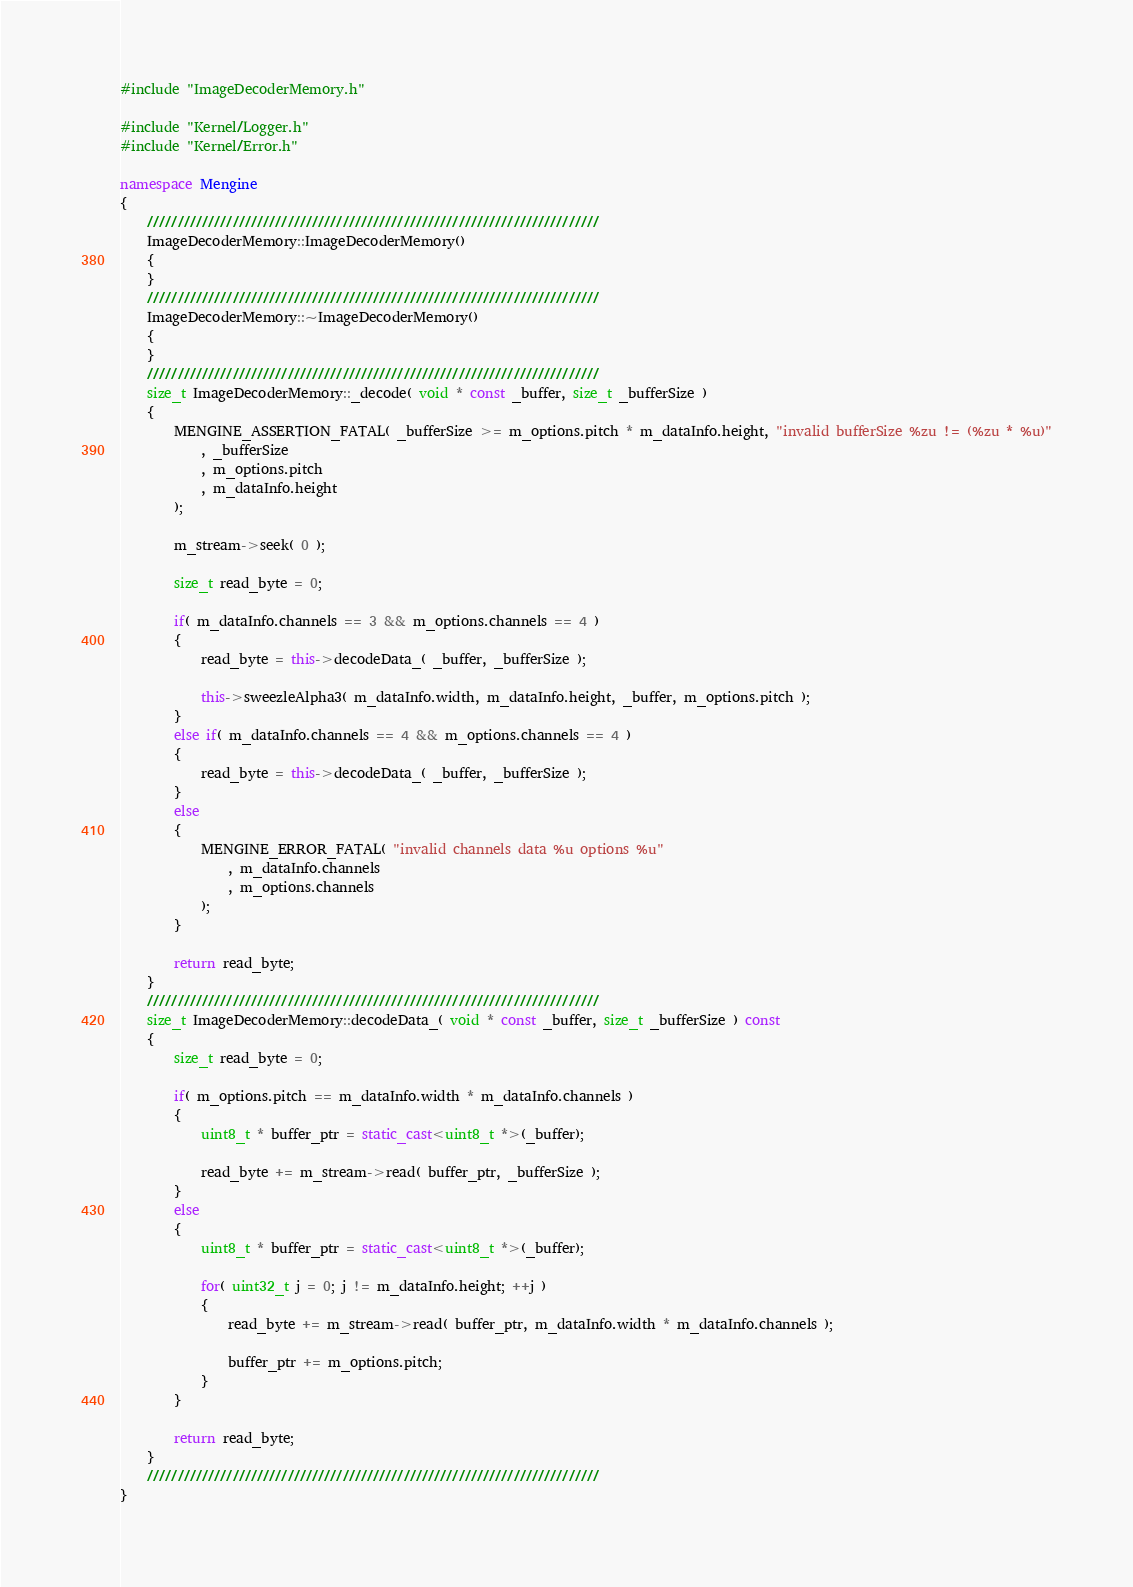Convert code to text. <code><loc_0><loc_0><loc_500><loc_500><_C++_>#include "ImageDecoderMemory.h"

#include "Kernel/Logger.h"
#include "Kernel/Error.h"

namespace Mengine
{
    //////////////////////////////////////////////////////////////////////////
    ImageDecoderMemory::ImageDecoderMemory()
    {
    }
    //////////////////////////////////////////////////////////////////////////
    ImageDecoderMemory::~ImageDecoderMemory()
    {
    }
    //////////////////////////////////////////////////////////////////////////
    size_t ImageDecoderMemory::_decode( void * const _buffer, size_t _bufferSize )
    {
        MENGINE_ASSERTION_FATAL( _bufferSize >= m_options.pitch * m_dataInfo.height, "invalid bufferSize %zu != (%zu * %u)"
            , _bufferSize
            , m_options.pitch
            , m_dataInfo.height
        );

        m_stream->seek( 0 );

        size_t read_byte = 0;

        if( m_dataInfo.channels == 3 && m_options.channels == 4 )
        {
            read_byte = this->decodeData_( _buffer, _bufferSize );

            this->sweezleAlpha3( m_dataInfo.width, m_dataInfo.height, _buffer, m_options.pitch );
        }
        else if( m_dataInfo.channels == 4 && m_options.channels == 4 )
        {
            read_byte = this->decodeData_( _buffer, _bufferSize );
        }
        else
        {
            MENGINE_ERROR_FATAL( "invalid channels data %u options %u"
                , m_dataInfo.channels 
                , m_options.channels
            );
        }

        return read_byte;
    }
    //////////////////////////////////////////////////////////////////////////
    size_t ImageDecoderMemory::decodeData_( void * const _buffer, size_t _bufferSize ) const
    {
        size_t read_byte = 0;

        if( m_options.pitch == m_dataInfo.width * m_dataInfo.channels )
        {
            uint8_t * buffer_ptr = static_cast<uint8_t *>(_buffer);

            read_byte += m_stream->read( buffer_ptr, _bufferSize );
        }
        else
        {
            uint8_t * buffer_ptr = static_cast<uint8_t *>(_buffer);

            for( uint32_t j = 0; j != m_dataInfo.height; ++j )
            {
                read_byte += m_stream->read( buffer_ptr, m_dataInfo.width * m_dataInfo.channels );

                buffer_ptr += m_options.pitch;
            }
        }

        return read_byte;
    }
    //////////////////////////////////////////////////////////////////////////
}
</code> 